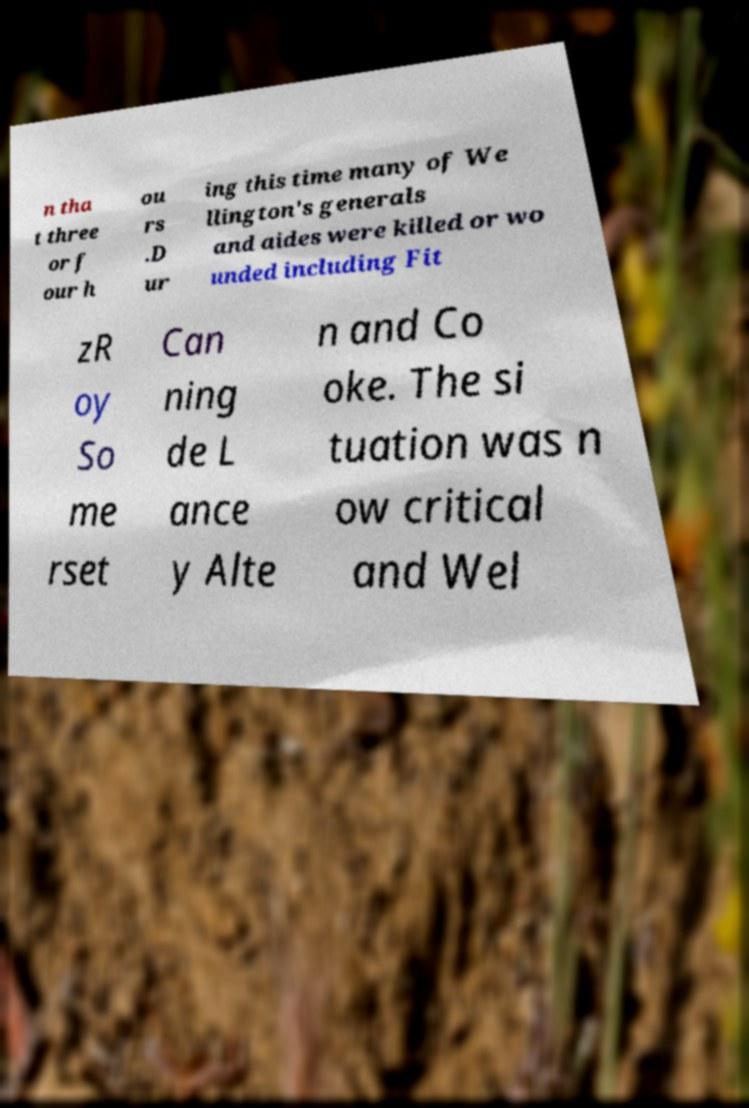What messages or text are displayed in this image? I need them in a readable, typed format. n tha t three or f our h ou rs .D ur ing this time many of We llington's generals and aides were killed or wo unded including Fit zR oy So me rset Can ning de L ance y Alte n and Co oke. The si tuation was n ow critical and Wel 